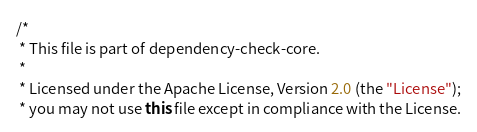<code> <loc_0><loc_0><loc_500><loc_500><_Java_>/*
 * This file is part of dependency-check-core.
 *
 * Licensed under the Apache License, Version 2.0 (the "License");
 * you may not use this file except in compliance with the License.</code> 